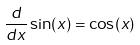<formula> <loc_0><loc_0><loc_500><loc_500>\frac { d } { d x } \sin ( x ) = \cos ( x )</formula> 